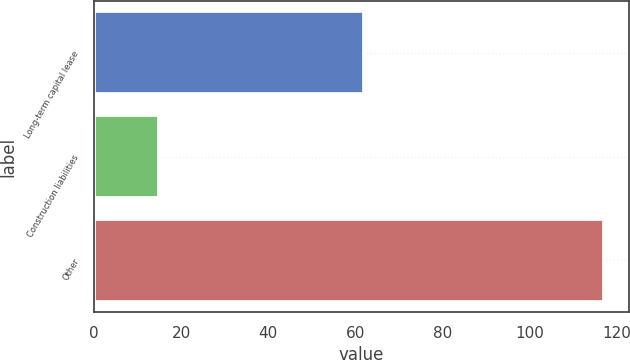<chart> <loc_0><loc_0><loc_500><loc_500><bar_chart><fcel>Long-term capital lease<fcel>Construction liabilities<fcel>Other<nl><fcel>62<fcel>15<fcel>117<nl></chart> 